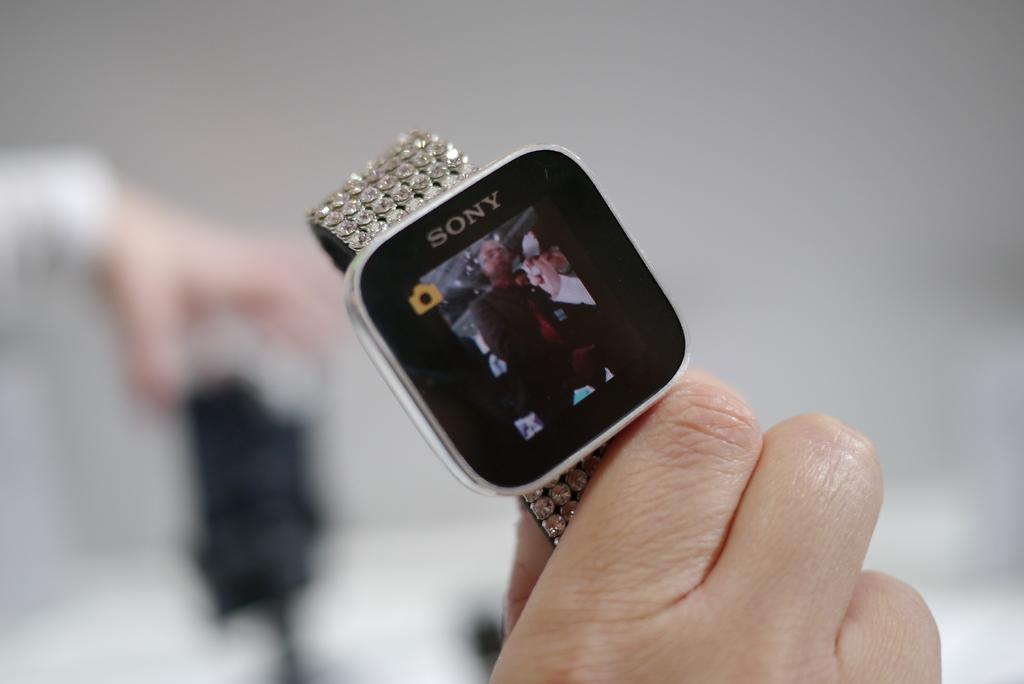<image>
Present a compact description of the photo's key features. A Sony watch with a rhinestone band is being held in someone's hand. 